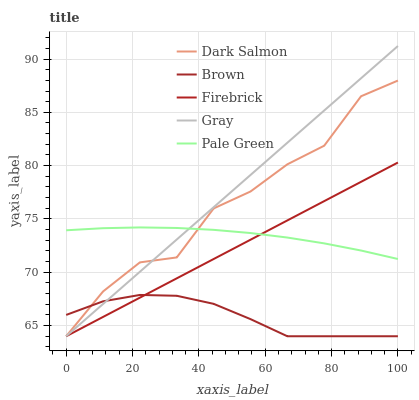Does Brown have the minimum area under the curve?
Answer yes or no. Yes. Does Gray have the maximum area under the curve?
Answer yes or no. Yes. Does Firebrick have the minimum area under the curve?
Answer yes or no. No. Does Firebrick have the maximum area under the curve?
Answer yes or no. No. Is Gray the smoothest?
Answer yes or no. Yes. Is Dark Salmon the roughest?
Answer yes or no. Yes. Is Firebrick the smoothest?
Answer yes or no. No. Is Firebrick the roughest?
Answer yes or no. No. Does Brown have the lowest value?
Answer yes or no. Yes. Does Pale Green have the lowest value?
Answer yes or no. No. Does Gray have the highest value?
Answer yes or no. Yes. Does Firebrick have the highest value?
Answer yes or no. No. Is Brown less than Pale Green?
Answer yes or no. Yes. Is Pale Green greater than Brown?
Answer yes or no. Yes. Does Firebrick intersect Dark Salmon?
Answer yes or no. Yes. Is Firebrick less than Dark Salmon?
Answer yes or no. No. Is Firebrick greater than Dark Salmon?
Answer yes or no. No. Does Brown intersect Pale Green?
Answer yes or no. No. 